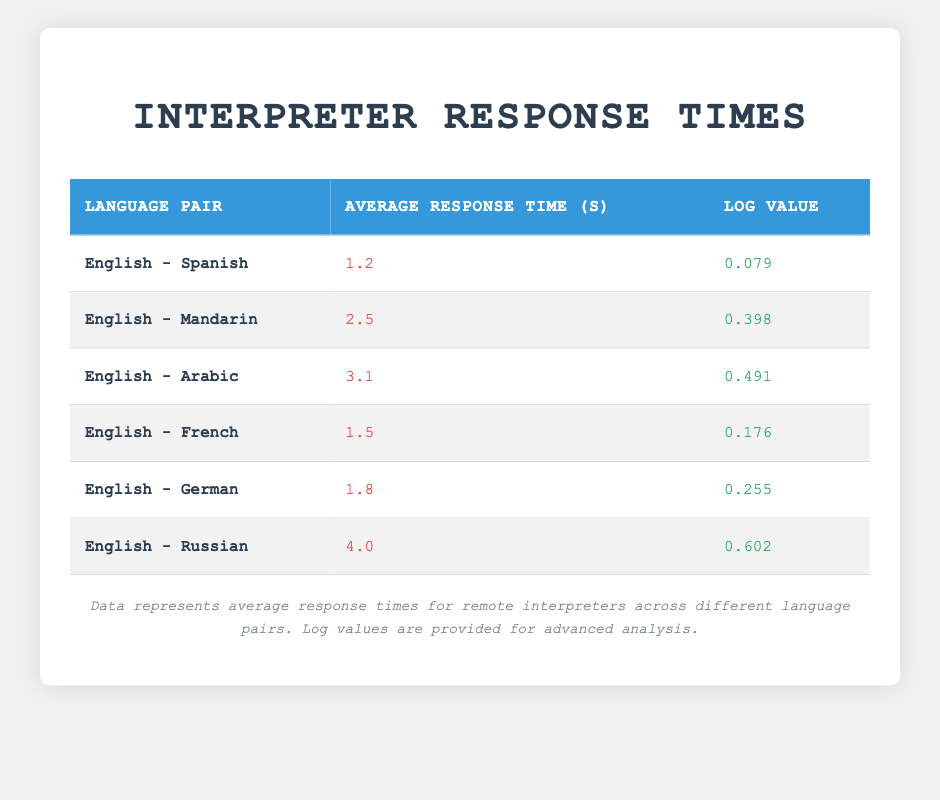What is the average response time for the English - Spanish language pair? The table shows an average response time of 1.2 seconds for the English - Spanish language pair listed under the "Average Response Time (s)" column.
Answer: 1.2 seconds Which language pair has the highest average response time? According to the table, the English - Russian language pair has the highest average response time of 4.0 seconds.
Answer: English - Russian What is the log value for the English - Arabic language pair? The table lists the log value for the English - Arabic language pair as 0.491, found in the "Log Value" column beside that specific pair.
Answer: 0.491 What is the difference in average response time between English - Mandarin and English - French? The average response time for English - Mandarin is 2.5 seconds and for English - French is 1.5 seconds. The difference is 2.5 - 1.5 = 1.0 seconds.
Answer: 1.0 seconds Is the average response time for English - German less than 2 seconds? The table shows that the average response time for English - German is 1.8 seconds, which is indeed less than 2 seconds.
Answer: Yes What is the average response time for all language pairs listed? To find the average, sum the average response times: 1.2 + 2.5 + 3.1 + 1.5 + 1.8 + 4.0 = 14.1 seconds. There are 6 language pairs, so the average is 14.1 / 6 = 2.35 seconds.
Answer: 2.35 seconds Which language pair has the lowest log value? The table indicates that the English - Spanish language pair has the lowest log value of 0.079, as seen in the "Log Value" column for that row.
Answer: English - Spanish Are there any language pairs with an average response time greater than 3 seconds? The table shows that the English - Arabic and English - Russian pairs have average response times of 3.1 and 4.0 seconds respectively, both greater than 3 seconds.
Answer: Yes What is the sum of the log values for English - French and English - German? The log value for English - French is 0.176 and for English - German is 0.255. The sum is 0.176 + 0.255 = 0.431.
Answer: 0.431 